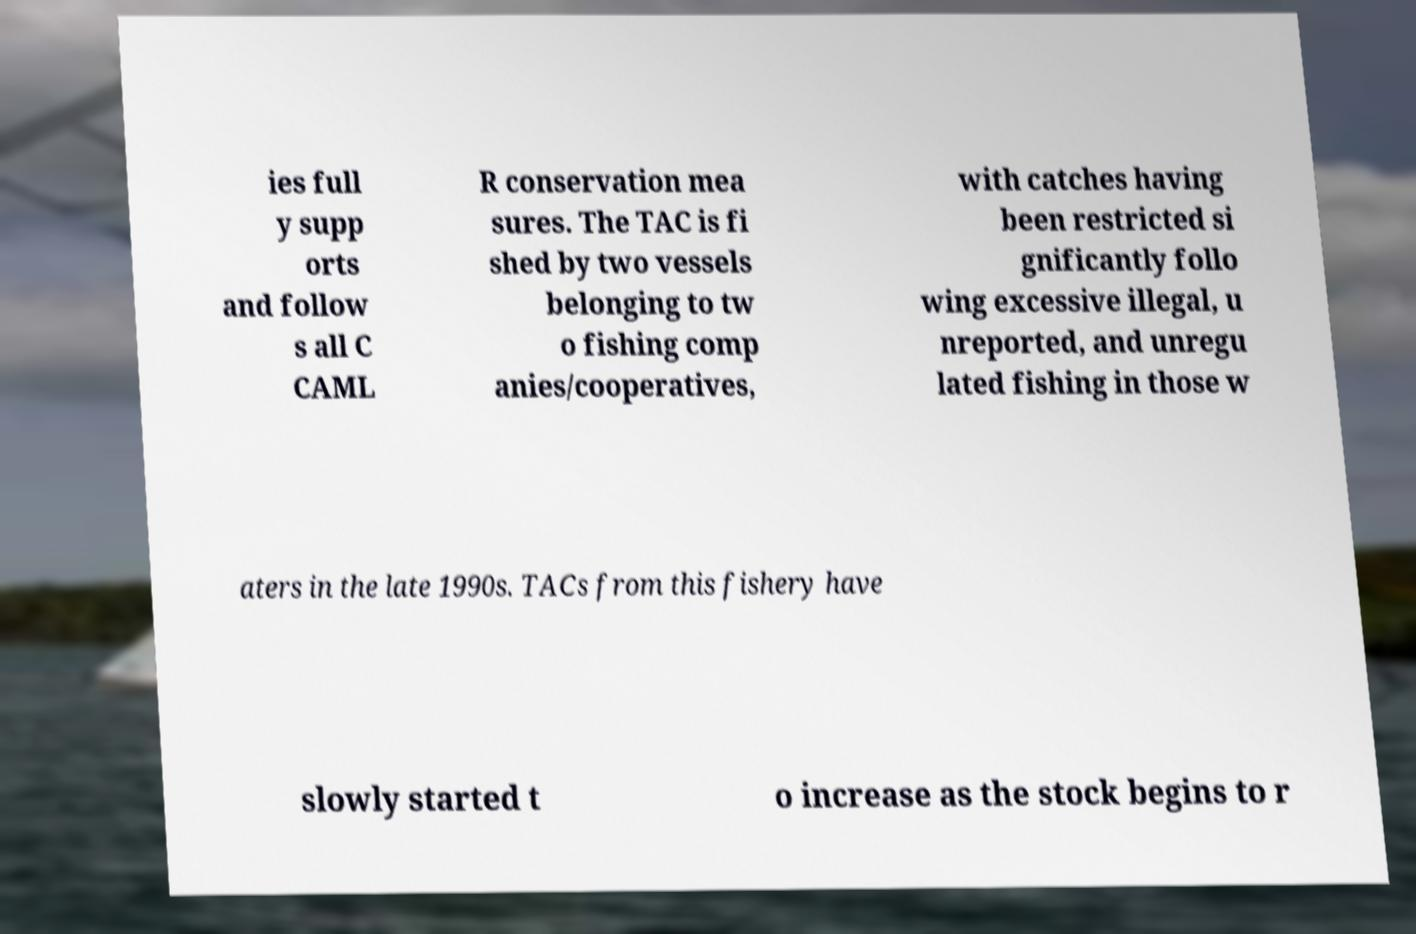For documentation purposes, I need the text within this image transcribed. Could you provide that? ies full y supp orts and follow s all C CAML R conservation mea sures. The TAC is fi shed by two vessels belonging to tw o fishing comp anies/cooperatives, with catches having been restricted si gnificantly follo wing excessive illegal, u nreported, and unregu lated fishing in those w aters in the late 1990s. TACs from this fishery have slowly started t o increase as the stock begins to r 